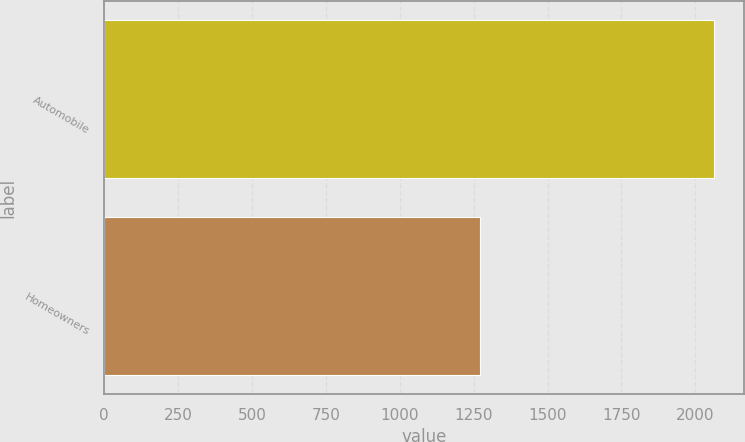Convert chart to OTSL. <chart><loc_0><loc_0><loc_500><loc_500><bar_chart><fcel>Automobile<fcel>Homeowners<nl><fcel>2062<fcel>1272<nl></chart> 